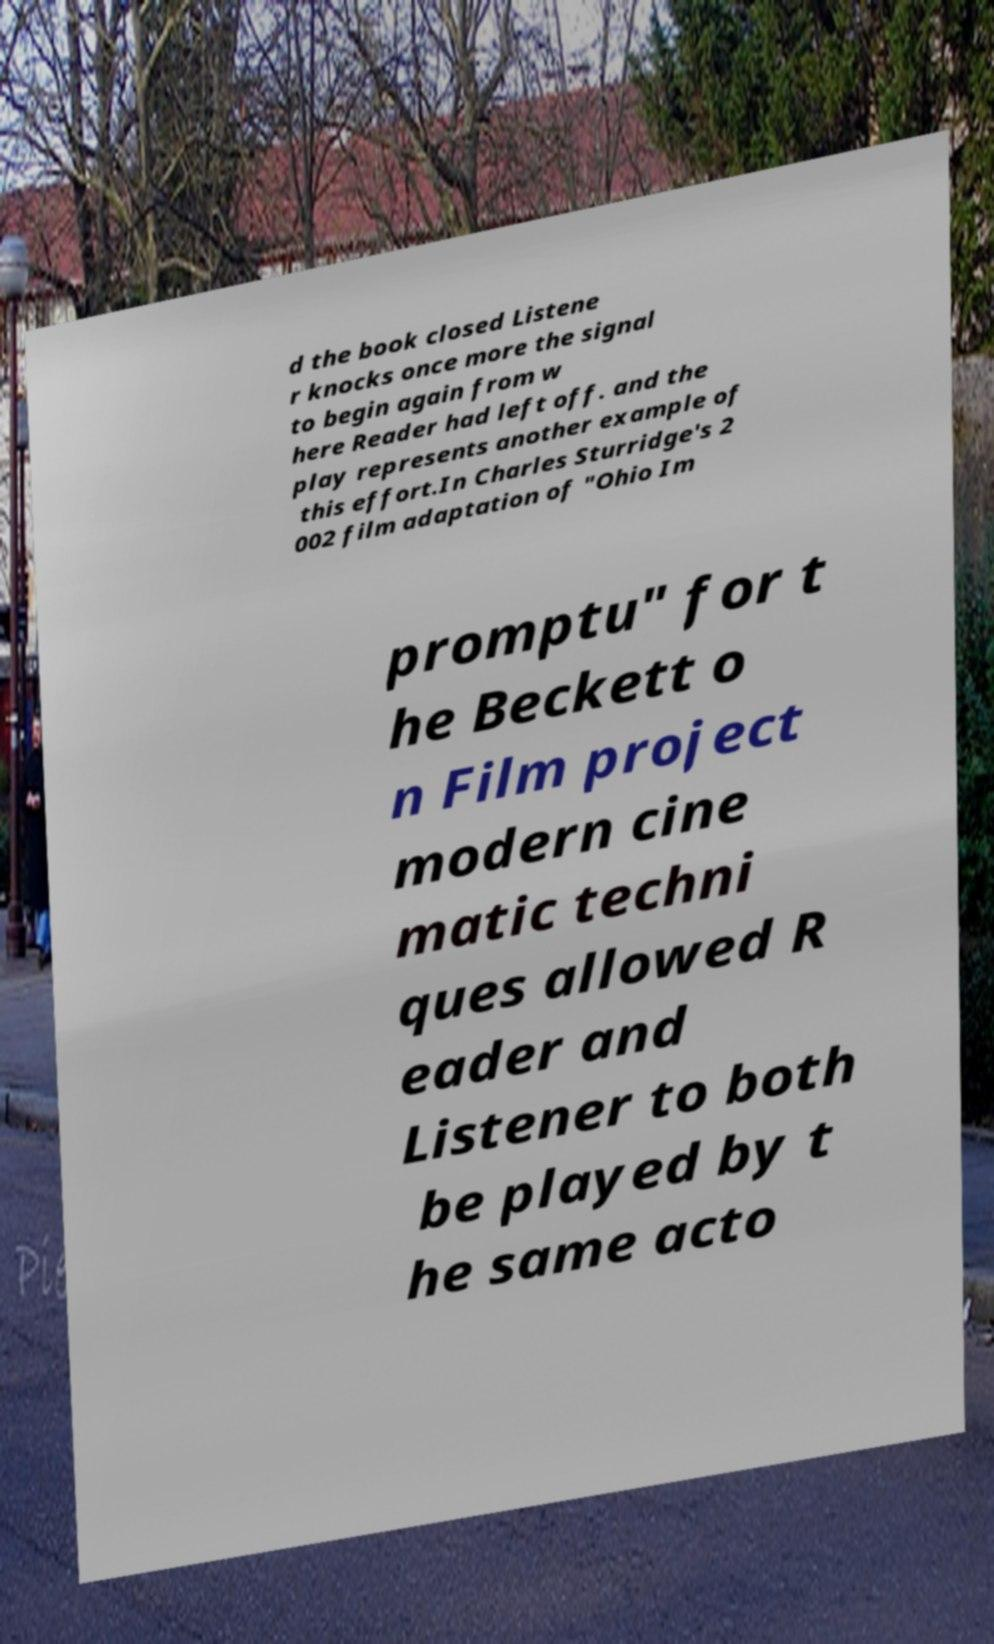For documentation purposes, I need the text within this image transcribed. Could you provide that? d the book closed Listene r knocks once more the signal to begin again from w here Reader had left off. and the play represents another example of this effort.In Charles Sturridge's 2 002 film adaptation of "Ohio Im promptu" for t he Beckett o n Film project modern cine matic techni ques allowed R eader and Listener to both be played by t he same acto 